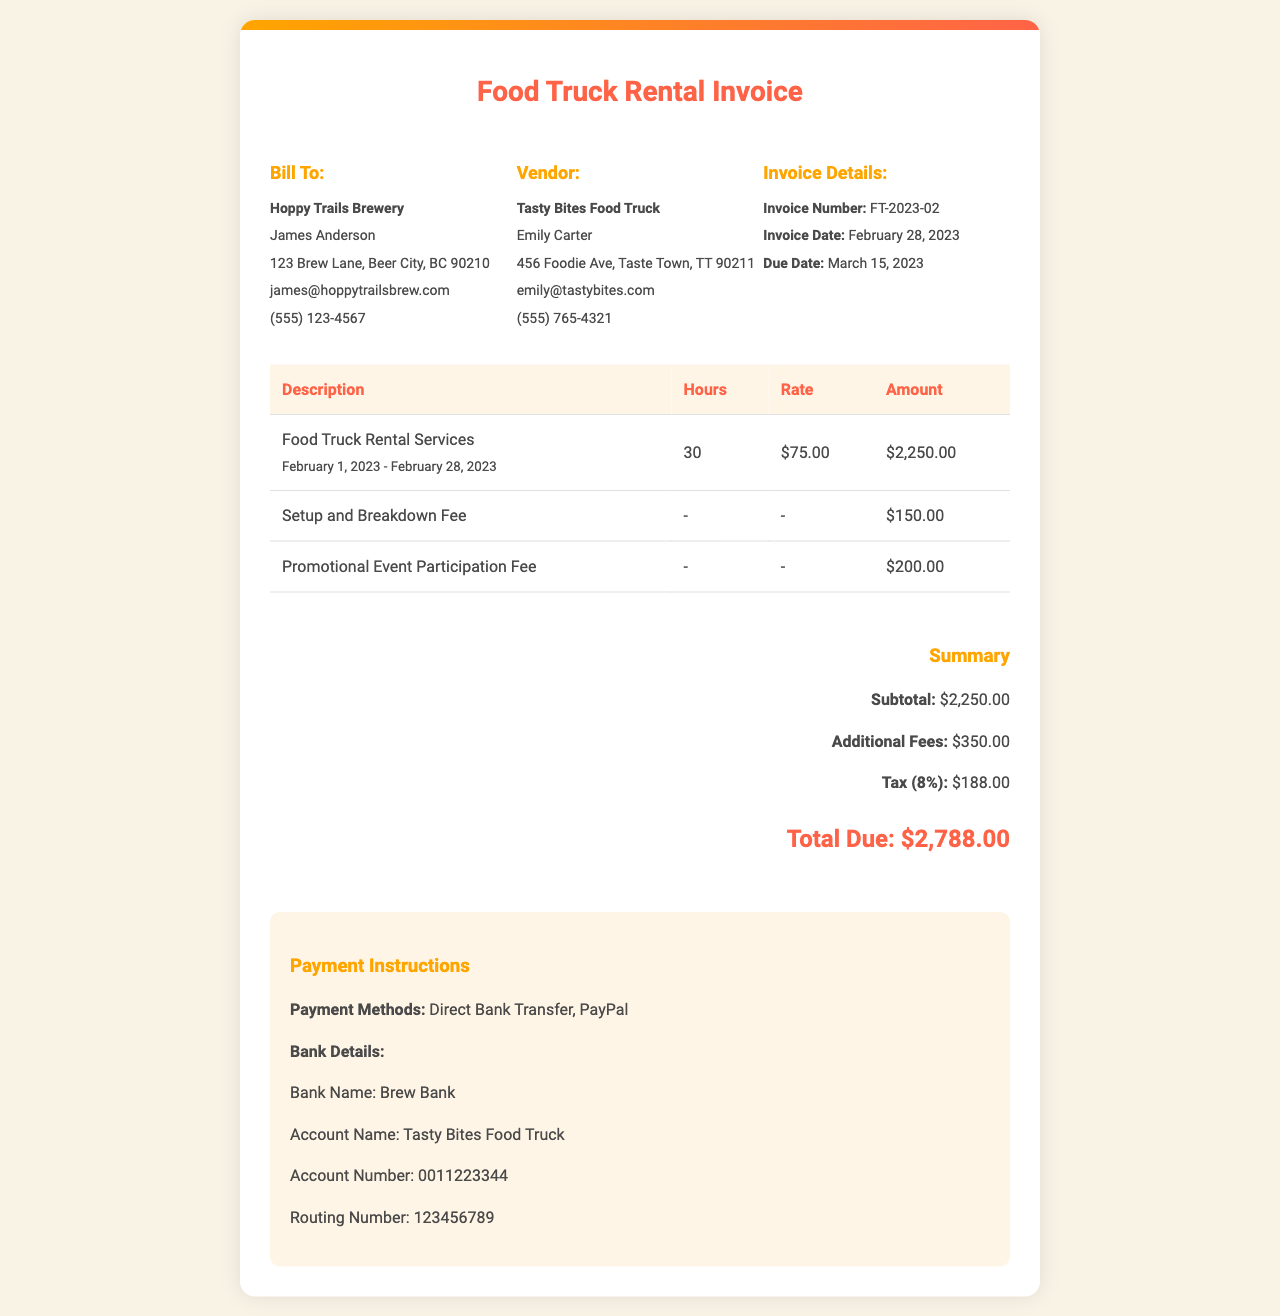What is the invoice number? The invoice number is a unique identifier for the invoice, which is FT-2023-02.
Answer: FT-2023-02 What is the total amount due? The total amount due at the bottom of the summary section is highlighted, which is $2,788.00.
Answer: $2,788.00 Who is the vendor for this invoice? The vendor is the entity providing services, which is Tasty Bites Food Truck.
Answer: Tasty Bites Food Truck How many hours of food truck rental services are billed? The total number of hours for food truck rental services is specified in the table as 30 hours.
Answer: 30 What is the tax rate applied to the invoice? The tax rate is indicated as 8% in the summary section of the invoice.
Answer: 8% What is the amount charged for the setup and breakdown fee? The amount for the setup and breakdown fee is listed separate from the rental services, which is $150.00.
Answer: $150.00 When is the payment due date? The due date provided in the invoice details is clearly stated, which is March 15, 2023.
Answer: March 15, 2023 What fee is associated with promotional event participation? The fee for promotional event participation is mentioned in the table, which is $200.00.
Answer: $200.00 